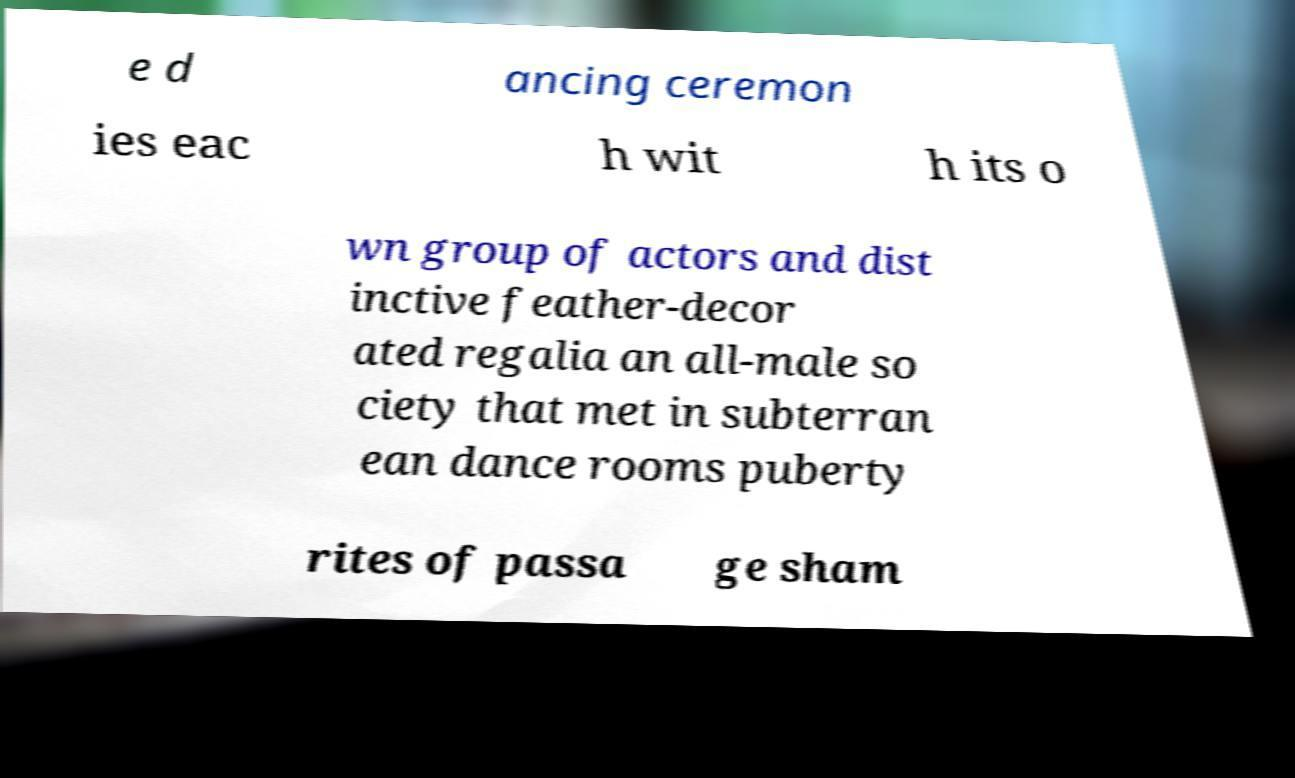Please read and relay the text visible in this image. What does it say? e d ancing ceremon ies eac h wit h its o wn group of actors and dist inctive feather-decor ated regalia an all-male so ciety that met in subterran ean dance rooms puberty rites of passa ge sham 